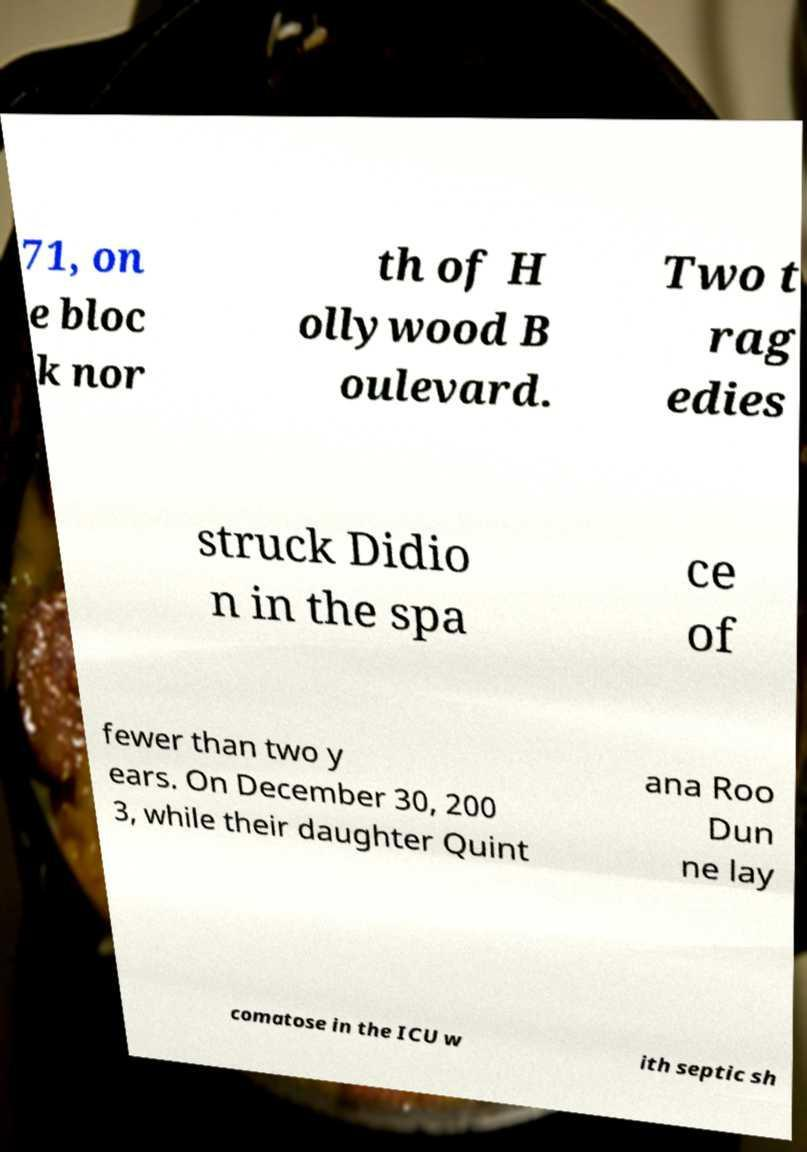Could you extract and type out the text from this image? 71, on e bloc k nor th of H ollywood B oulevard. Two t rag edies struck Didio n in the spa ce of fewer than two y ears. On December 30, 200 3, while their daughter Quint ana Roo Dun ne lay comatose in the ICU w ith septic sh 